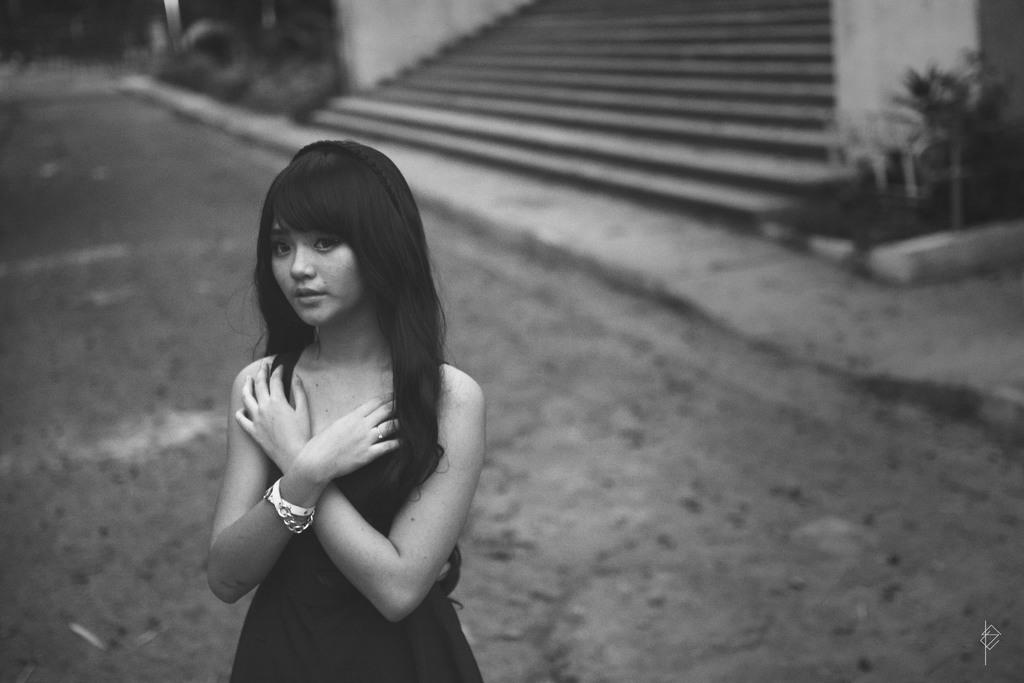What is the color scheme of the image? The image is black and white. Can you describe the main subject in the image? There is a lady in the image. What can be seen in the background of the image? There are steps and plants in the background of the image. How would you describe the quality of the background? The background is blurry. What type of oranges are being served at the event in the image? There is no event or oranges present in the image; it features a lady with a blurry background. Can you tell me how many bags of popcorn are visible in the image? There are no bags of popcorn present in the image. 